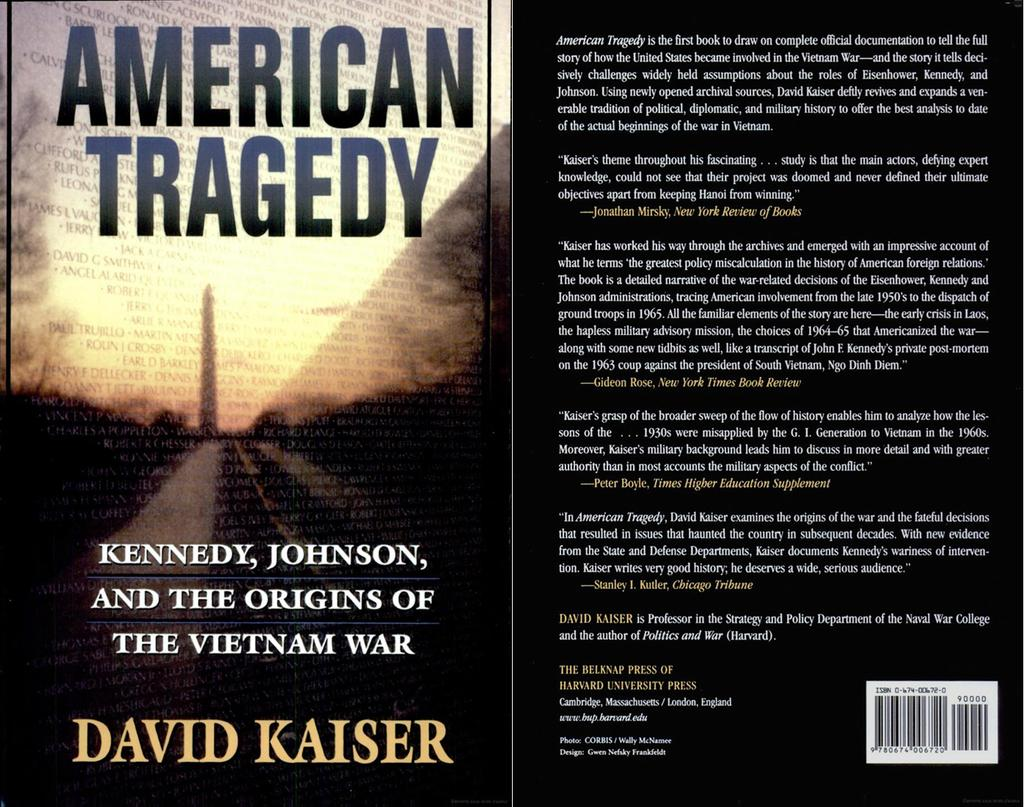<image>
Render a clear and concise summary of the photo. A book by David Kaiser is open on a table. 